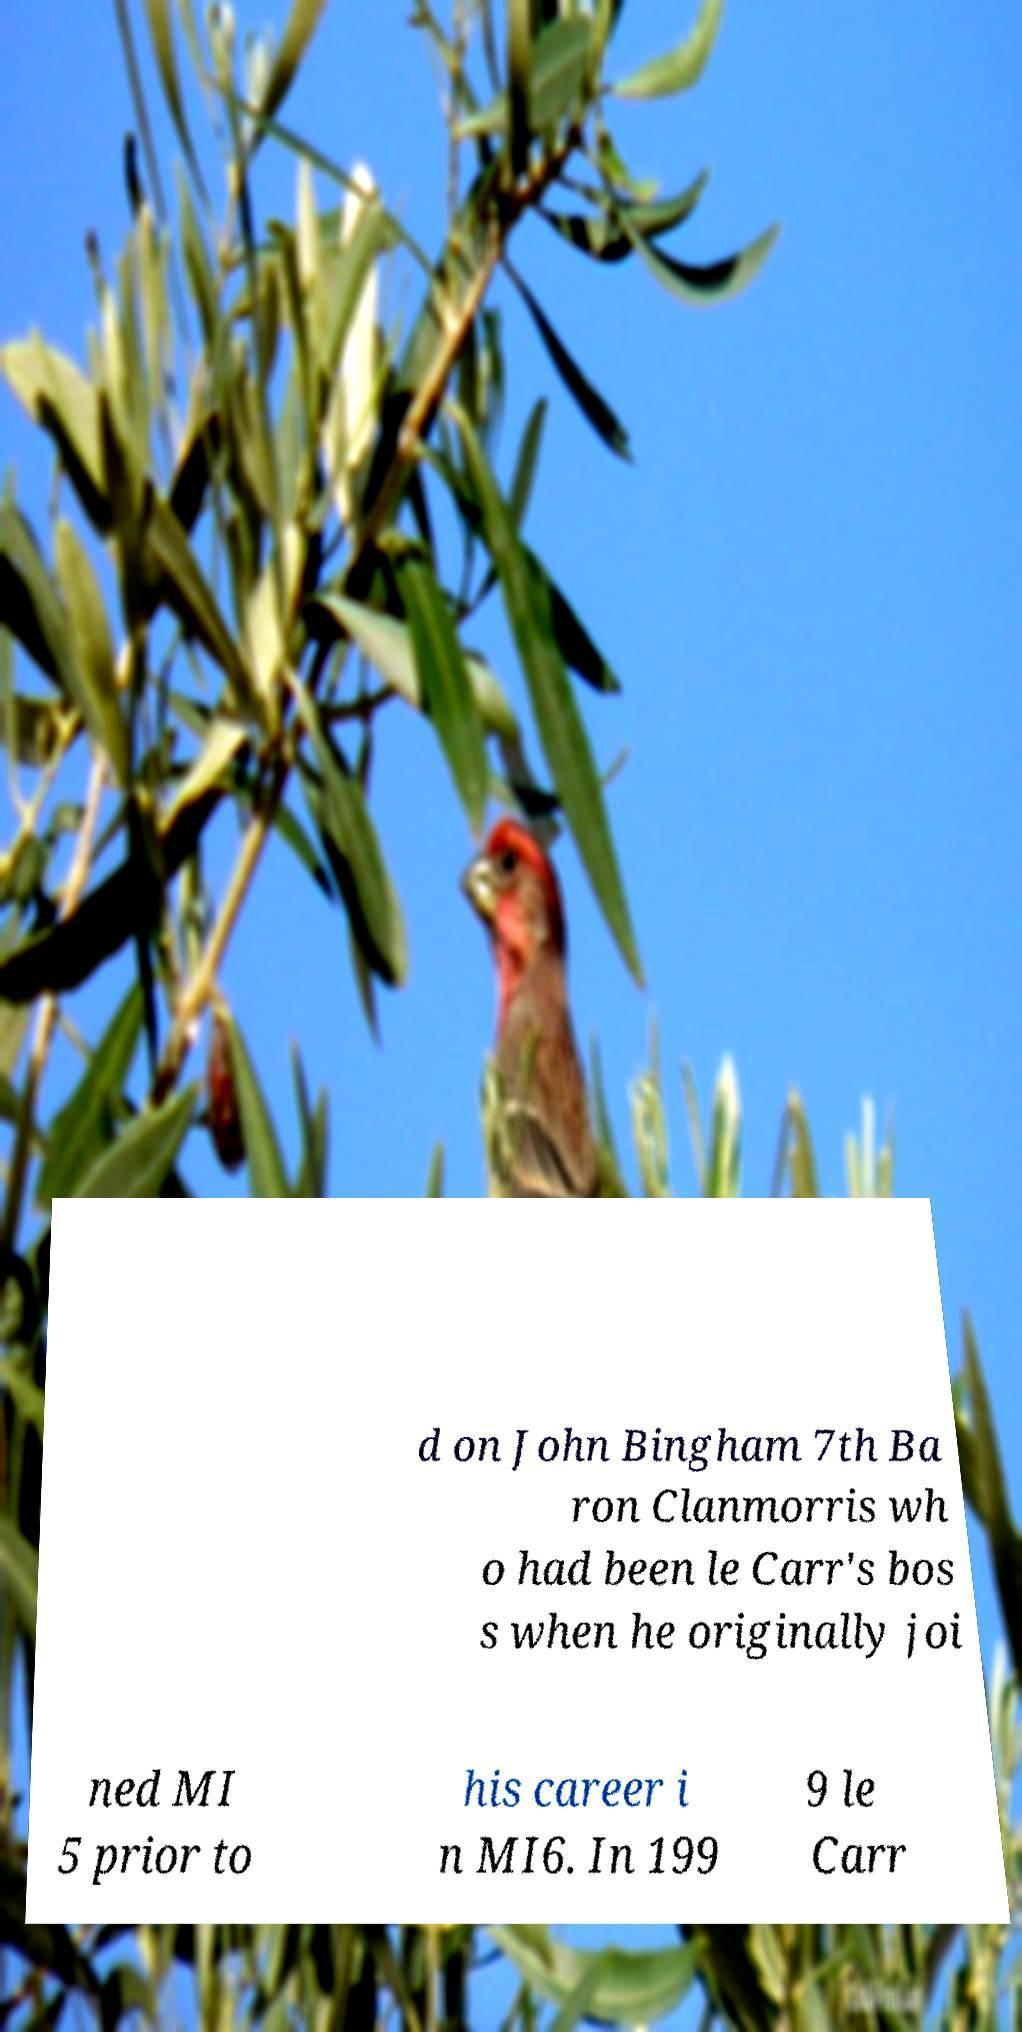Could you assist in decoding the text presented in this image and type it out clearly? d on John Bingham 7th Ba ron Clanmorris wh o had been le Carr's bos s when he originally joi ned MI 5 prior to his career i n MI6. In 199 9 le Carr 